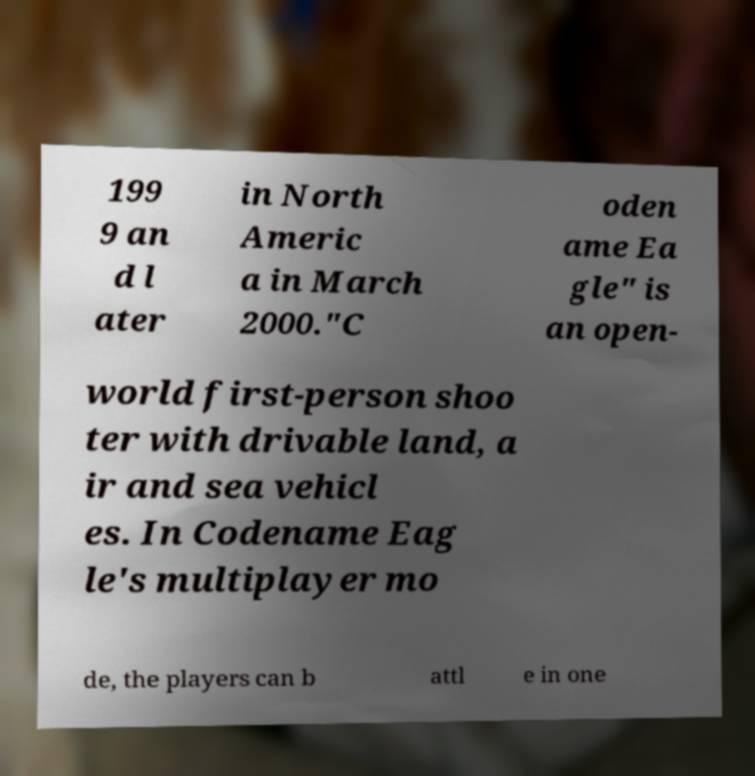Can you accurately transcribe the text from the provided image for me? 199 9 an d l ater in North Americ a in March 2000."C oden ame Ea gle" is an open- world first-person shoo ter with drivable land, a ir and sea vehicl es. In Codename Eag le's multiplayer mo de, the players can b attl e in one 